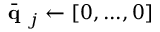Convert formula to latex. <formula><loc_0><loc_0><loc_500><loc_500>\bar { q } _ { j } \leftarrow [ 0 , \dots , 0 ]</formula> 